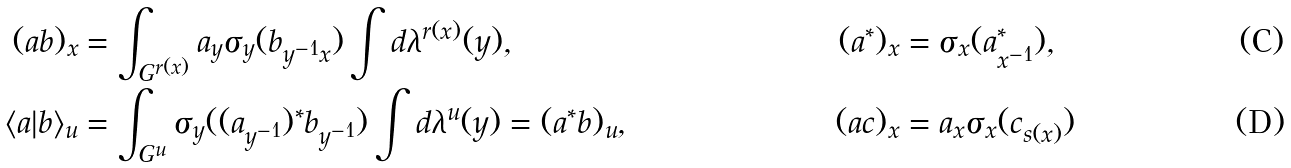Convert formula to latex. <formula><loc_0><loc_0><loc_500><loc_500>( a b ) _ { x } & = \int _ { G ^ { r ( x ) } } a _ { y } \sigma _ { y } ( b _ { y ^ { - 1 } x } ) \int d \lambda ^ { r ( x ) } ( y ) , & ( a ^ { * } ) _ { x } & = \sigma _ { x } ( a ^ { * } _ { x ^ { - 1 } } ) , \\ \langle a | b \rangle _ { u } & = \int _ { G ^ { u } } \sigma _ { y } ( ( a _ { y ^ { - 1 } } ) ^ { * } b _ { y ^ { - 1 } } ) \int d \lambda ^ { u } ( y ) = ( a ^ { * } b ) _ { u } , & ( a c ) _ { x } & = a _ { x } \sigma _ { x } ( c _ { s ( x ) } )</formula> 